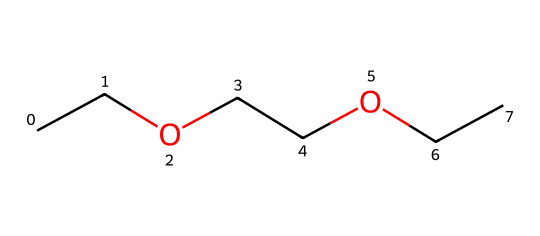What is the total number of carbon (C) atoms in this compound? By examining the SMILES representation, "CCOCCOCC," we count each "C" symbol. There are three segments of "CC," which each represent two carbon atoms, totaling six carbon atoms in the structure.
Answer: six How many ether groups are present in ethylene glycol diethyl ether? The SMILES representation "CCOCCOCC" includes two "O" symbols, which indicate the presence of two ether groups in the structure.
Answer: two What is the main function of ethylene glycol diethyl ether? Ethylene glycol diethyl ether is primarily used as a solvent in industrial cleaning products, as it is capable of dissolving various substances effectively.
Answer: solvent What type of chemical bonding is primarily found in ethers? Ethers feature an oxygen atom bonded to two alkyl or aryl groups through single covalent bonds, which is characteristic of their chemical structure.
Answer: covalent What is the functional group characteristic of ethers in this chemical? The presence of the oxygen atom (O) between two carbon chains is indicative of the ether functional group, which distinguishes ethers from other types of compounds.
Answer: ether Based on the structure, what can be said about the polarity of ethylene glycol diethyl ether? The presence of oxygen in the structure suggests that the molecule can engage in dipole-dipole interactions, indicating that it is polar, but the long carbon chains slightly lower its overall polarity.
Answer: polar 